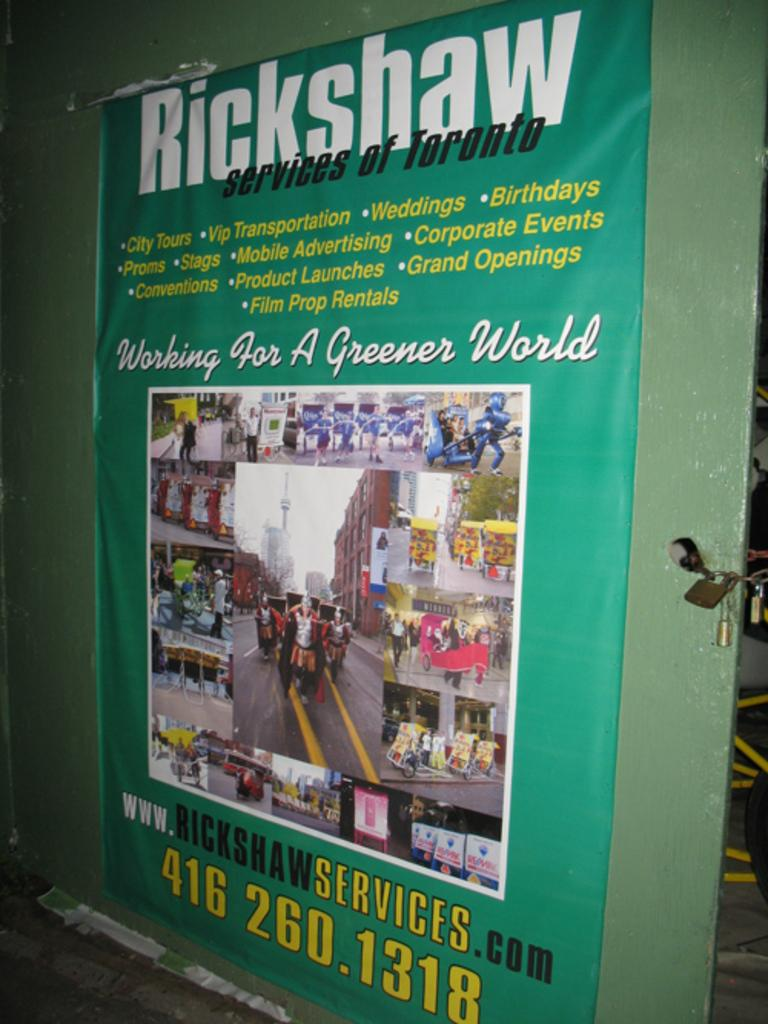<image>
Present a compact description of the photo's key features. a poster advertising rickshaw services of Toronto canada 